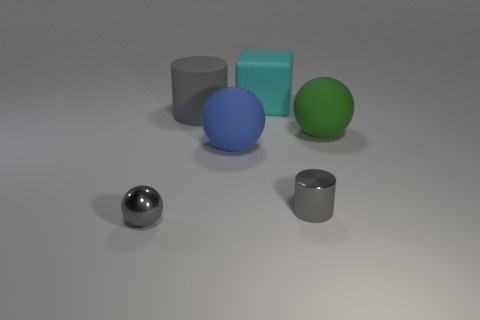Add 4 big gray matte cubes. How many objects exist? 10 Subtract all cylinders. How many objects are left? 4 Subtract 0 blue cylinders. How many objects are left? 6 Subtract all big gray cylinders. Subtract all small gray metal objects. How many objects are left? 3 Add 2 rubber cylinders. How many rubber cylinders are left? 3 Add 4 tiny brown matte cylinders. How many tiny brown matte cylinders exist? 4 